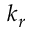<formula> <loc_0><loc_0><loc_500><loc_500>k _ { r }</formula> 